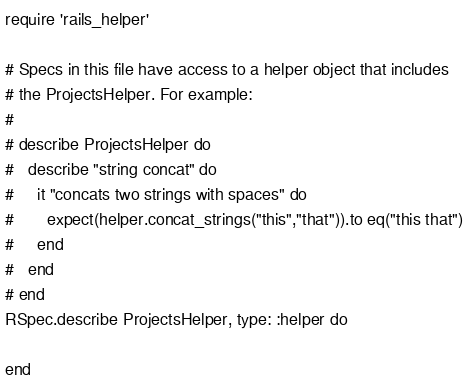<code> <loc_0><loc_0><loc_500><loc_500><_Ruby_>require 'rails_helper'

# Specs in this file have access to a helper object that includes
# the ProjectsHelper. For example:
#
# describe ProjectsHelper do
#   describe "string concat" do
#     it "concats two strings with spaces" do
#       expect(helper.concat_strings("this","that")).to eq("this that")
#     end
#   end
# end
RSpec.describe ProjectsHelper, type: :helper do
  
end
</code> 